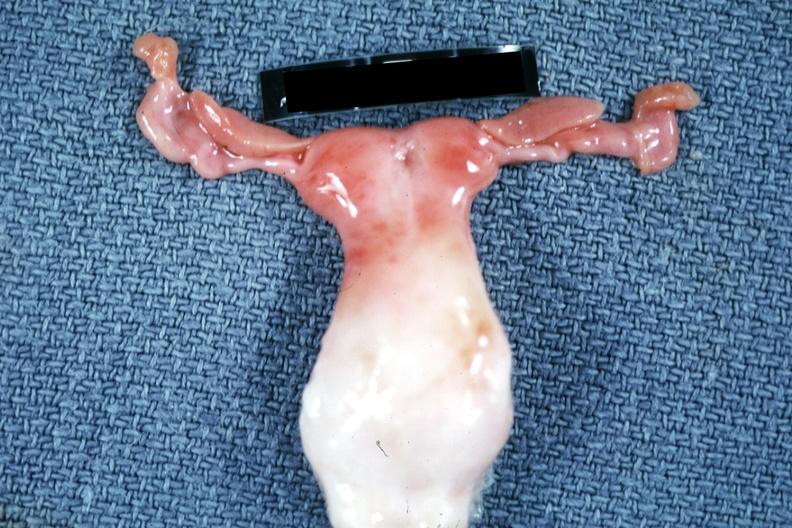s fibrinous peritonitis present?
Answer the question using a single word or phrase. No 